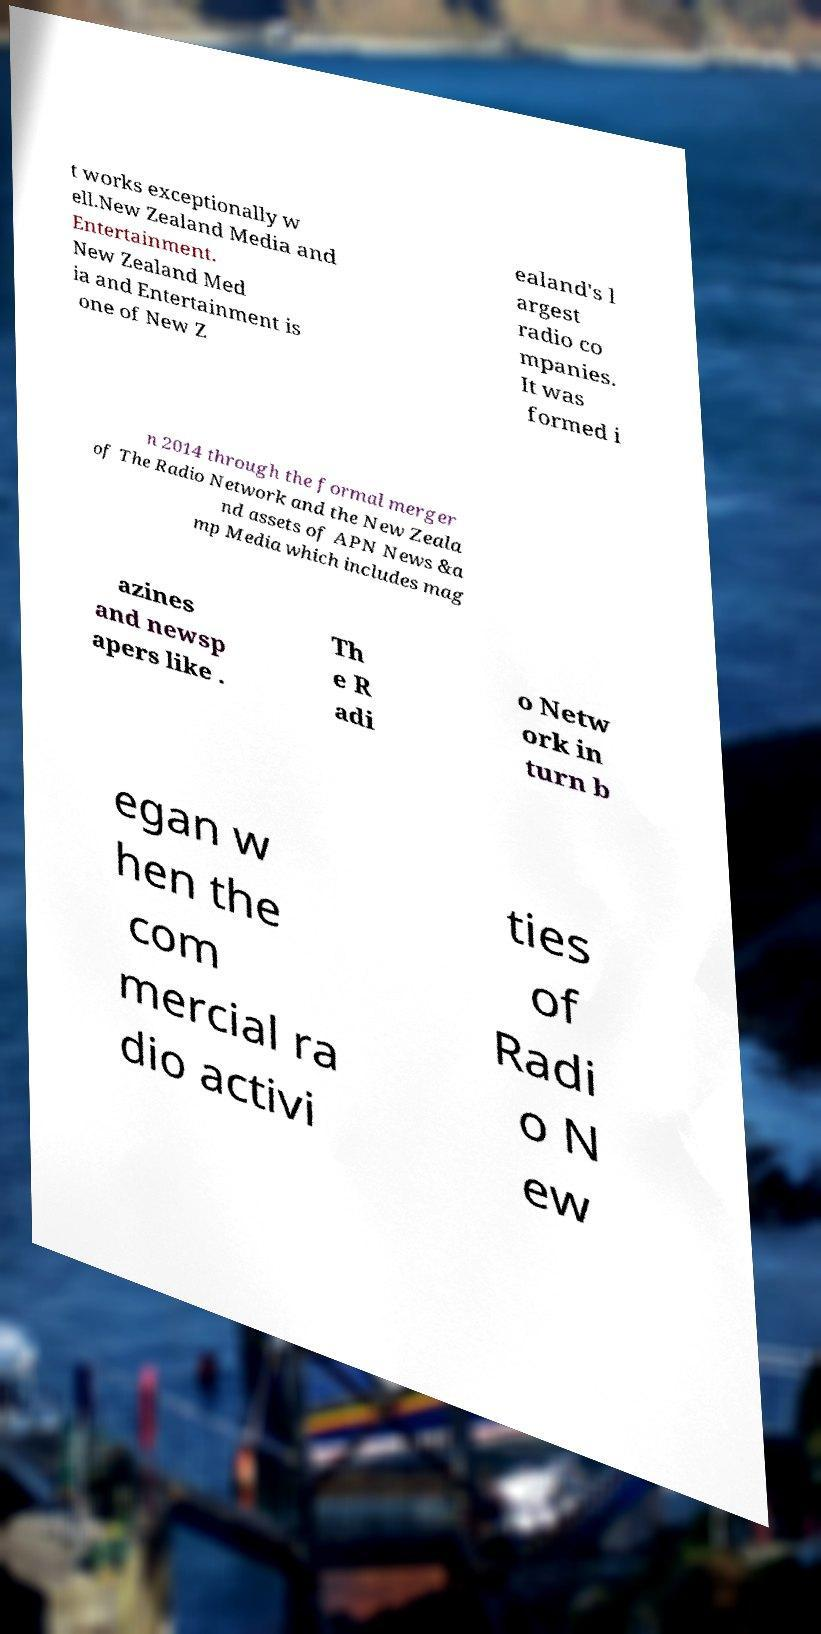Can you accurately transcribe the text from the provided image for me? t works exceptionally w ell.New Zealand Media and Entertainment. New Zealand Med ia and Entertainment is one of New Z ealand's l argest radio co mpanies. It was formed i n 2014 through the formal merger of The Radio Network and the New Zeala nd assets of APN News &a mp Media which includes mag azines and newsp apers like . Th e R adi o Netw ork in turn b egan w hen the com mercial ra dio activi ties of Radi o N ew 